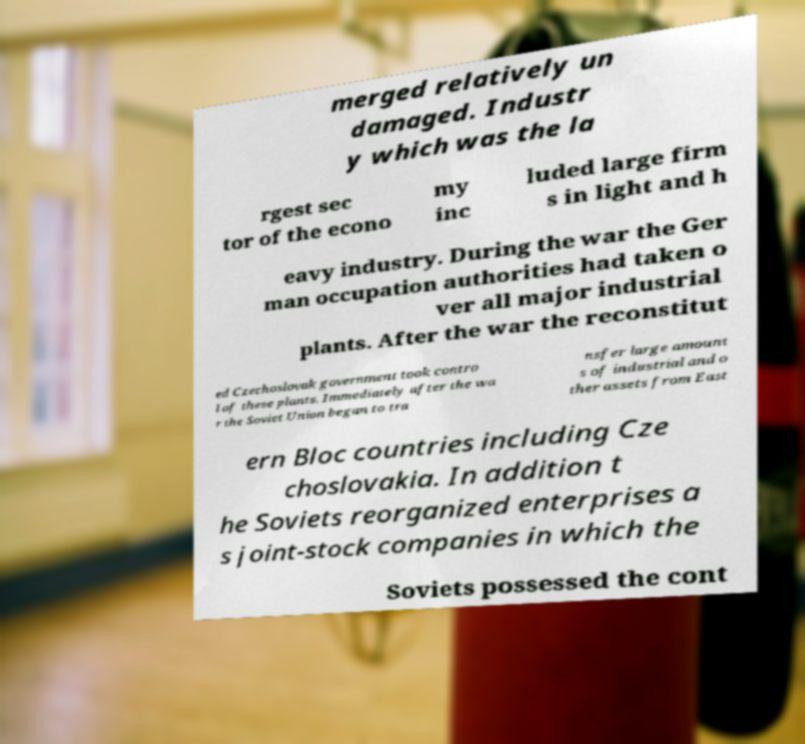Can you accurately transcribe the text from the provided image for me? merged relatively un damaged. Industr y which was the la rgest sec tor of the econo my inc luded large firm s in light and h eavy industry. During the war the Ger man occupation authorities had taken o ver all major industrial plants. After the war the reconstitut ed Czechoslovak government took contro l of these plants. Immediately after the wa r the Soviet Union began to tra nsfer large amount s of industrial and o ther assets from East ern Bloc countries including Cze choslovakia. In addition t he Soviets reorganized enterprises a s joint-stock companies in which the Soviets possessed the cont 